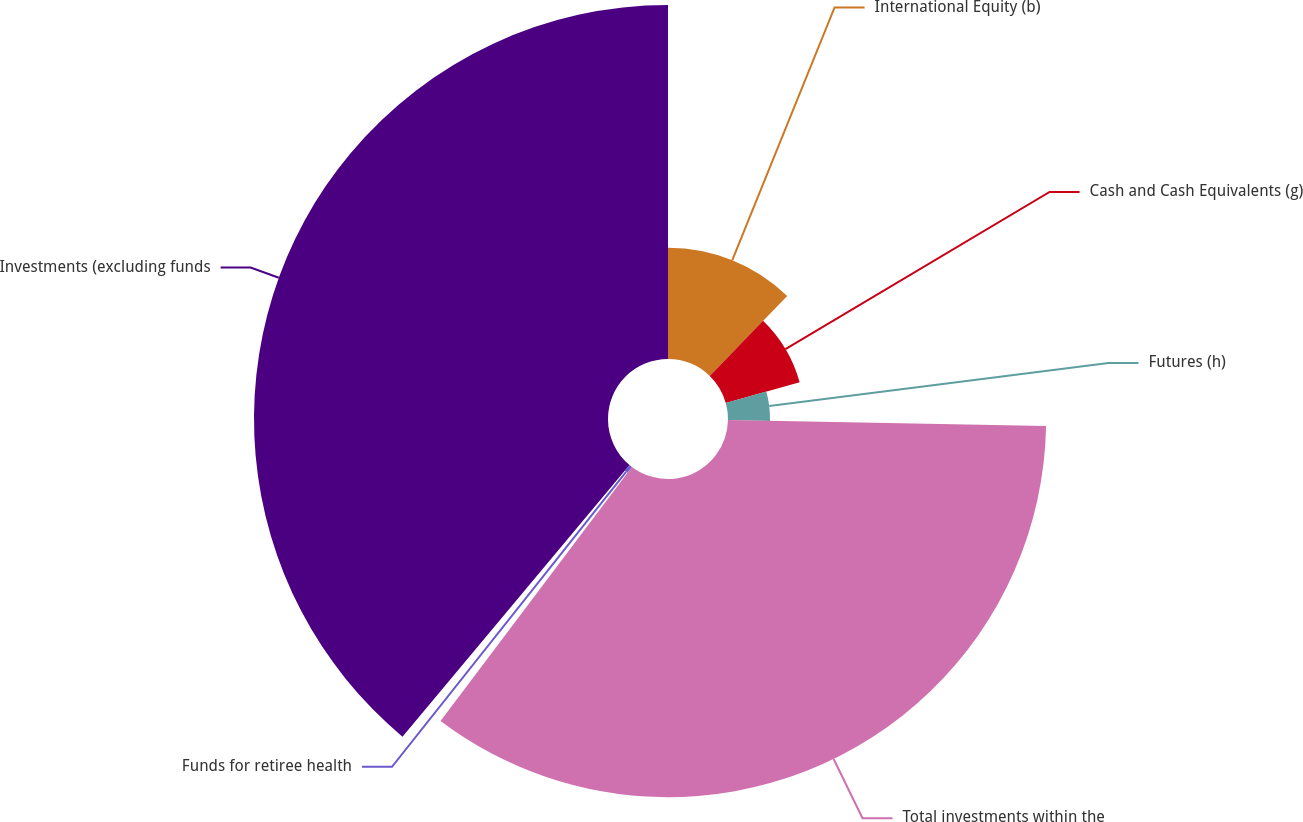Convert chart to OTSL. <chart><loc_0><loc_0><loc_500><loc_500><pie_chart><fcel>International Equity (b)<fcel>Cash and Cash Equivalents (g)<fcel>Futures (h)<fcel>Total investments within the<fcel>Funds for retiree health<fcel>Investments (excluding funds<nl><fcel>12.24%<fcel>8.43%<fcel>4.62%<fcel>34.97%<fcel>0.81%<fcel>38.91%<nl></chart> 